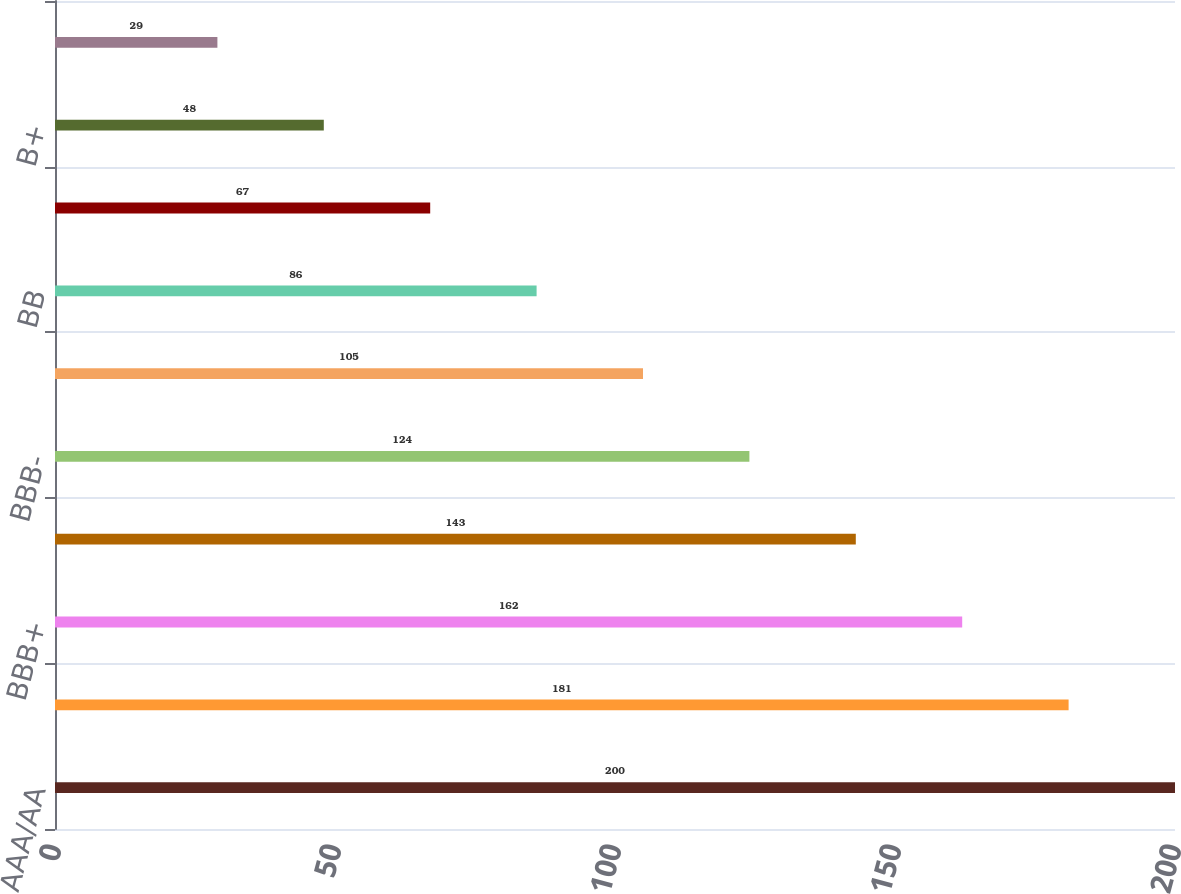Convert chart to OTSL. <chart><loc_0><loc_0><loc_500><loc_500><bar_chart><fcel>AAA/AA<fcel>A<fcel>BBB+<fcel>BBB<fcel>BBB-<fcel>BB+<fcel>BB<fcel>BB-<fcel>B+<fcel>B/B-<nl><fcel>200<fcel>181<fcel>162<fcel>143<fcel>124<fcel>105<fcel>86<fcel>67<fcel>48<fcel>29<nl></chart> 